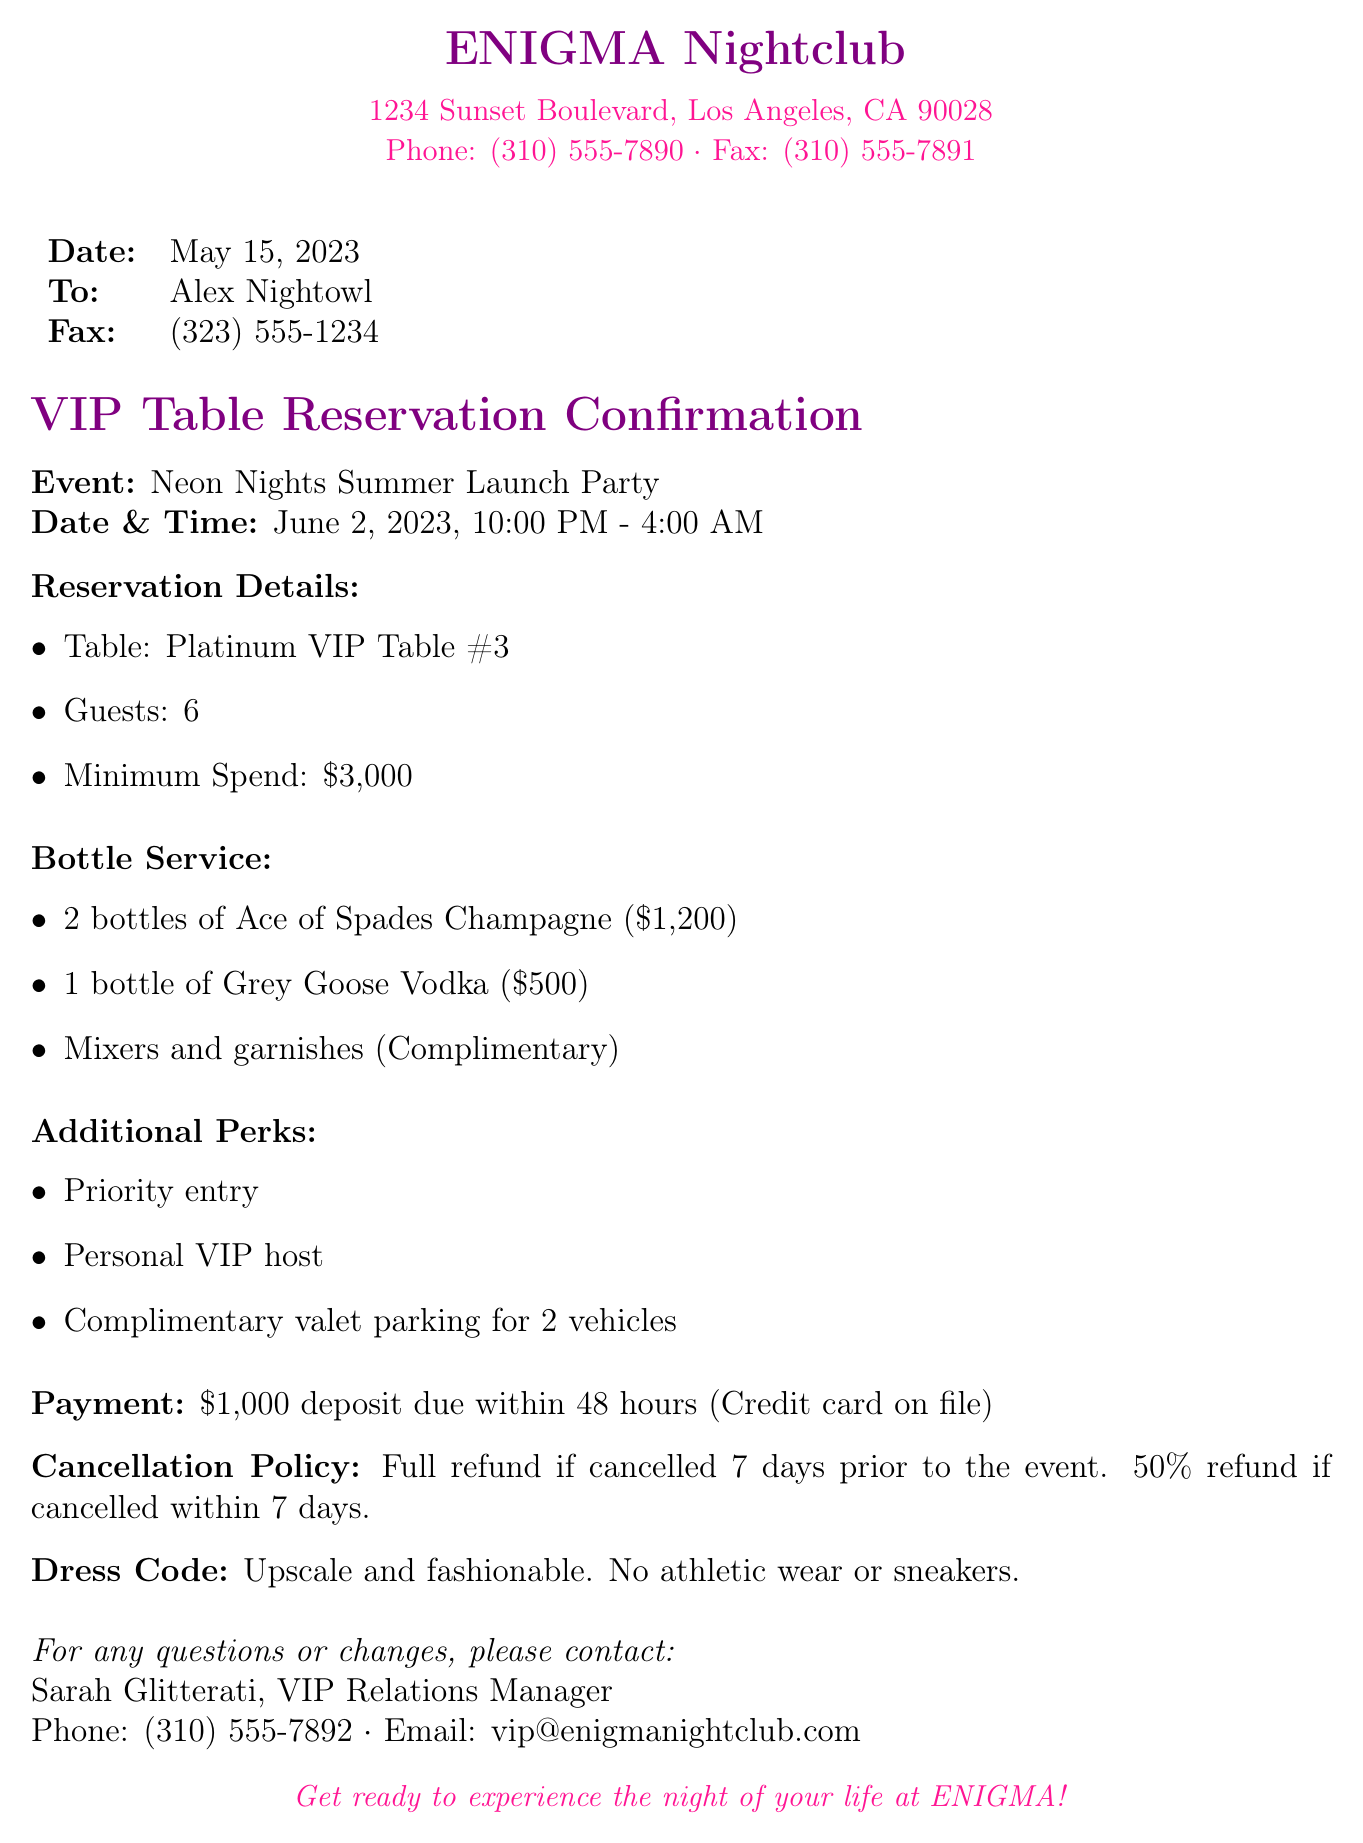What is the date of the event? The event is scheduled for June 2, 2023, as mentioned in the reservation confirmation.
Answer: June 2, 2023 How many guests are allowed at the table? The document specifies that the reservation is for 6 guests.
Answer: 6 What is the minimum spend required? The reservation details indicate a minimum spend of $3,000.
Answer: $3,000 Who is the contact person for questions? The fax lists Sarah Glitterati as the VIP Relations Manager for any inquiries.
Answer: Sarah Glitterati What is the deposit amount due within 48 hours? The payment section states that a deposit of $1,000 is required.
Answer: $1,000 What is the cancellation policy within 7 days? The cancellation policy specifies a 50% refund if canceled within 7 days of the event.
Answer: 50% refund What perks come with the VIP table reservation? The document lists priority entry, a personal VIP host, and complimentary valet parking as perks.
Answer: Priority entry, personal VIP host, complimentary valet parking What type of dress code is required? The dress code section specifies that guests should dress upscale and fashionable.
Answer: Upscale and fashionable 